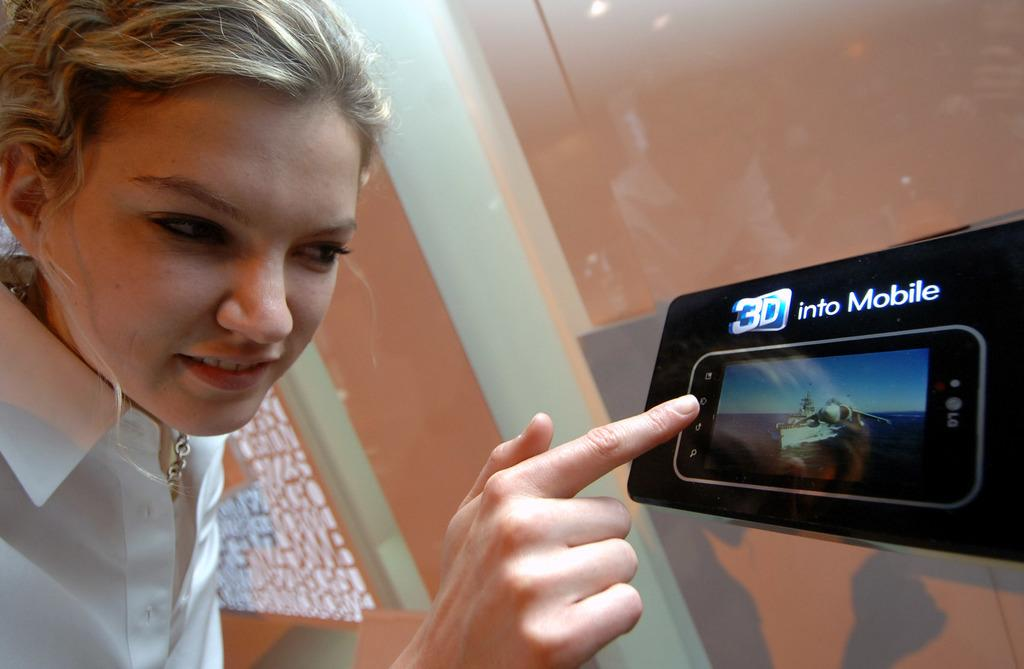What is the person in the image wearing? The person in the image is wearing a white dress. What can be seen on the screen in the image? The content of the screen is not visible in the image. What is in the background of the image? There is a wall in the background of the image. Is the person in the image playing basketball? There is no indication of a basketball or any basketball-related activity in the image. 